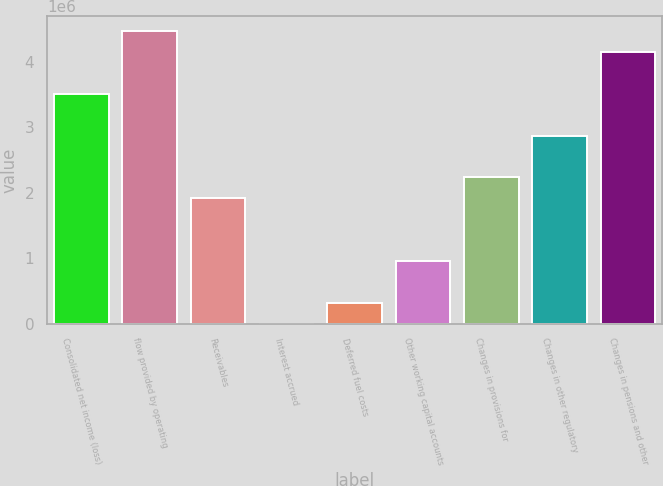Convert chart to OTSL. <chart><loc_0><loc_0><loc_500><loc_500><bar_chart><fcel>Consolidated net income (loss)<fcel>flow provided by operating<fcel>Receivables<fcel>Interest accrued<fcel>Deferred fuel costs<fcel>Other working capital accounts<fcel>Changes in provisions for<fcel>Changes in other regulatory<fcel>Changes in pensions and other<nl><fcel>3.50777e+06<fcel>4.46344e+06<fcel>1.915e+06<fcel>3667<fcel>322222<fcel>959333<fcel>2.23355e+06<fcel>2.87066e+06<fcel>4.14488e+06<nl></chart> 